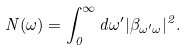<formula> <loc_0><loc_0><loc_500><loc_500>N ( \omega ) = \int ^ { \infty } _ { 0 } d \omega ^ { \prime } | \beta _ { \omega ^ { \prime } \omega } | ^ { 2 } .</formula> 